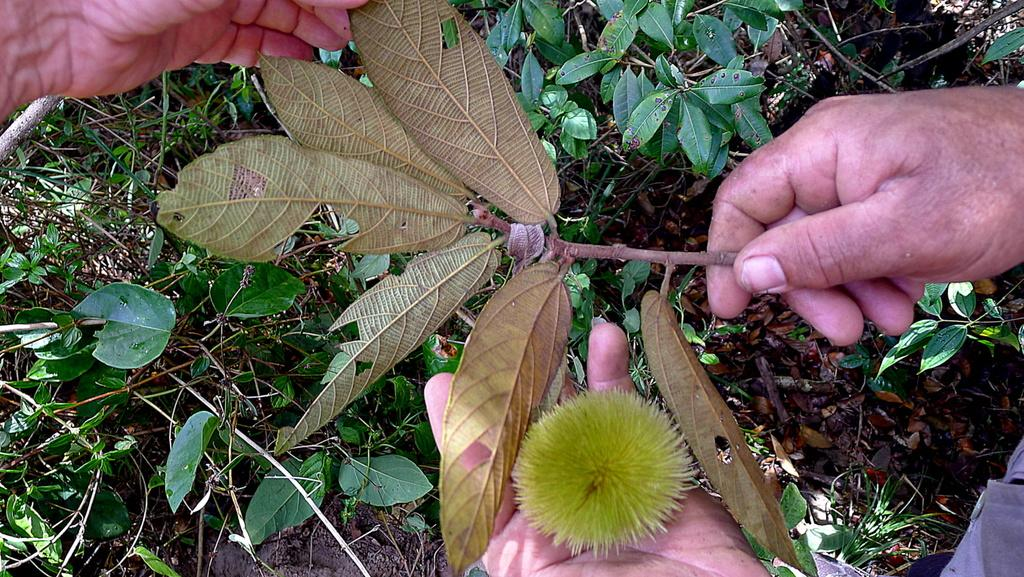Who or what is present in the image? There is a person in the image. What is the person holding in the image? The person is holding a stem of a plant. Are there any other plants visible in the image? Yes, there are other plants visible on the floor. What type of bait is the person using to catch fish in the image? There is no indication of fishing or bait in the image; the person is holding a stem of a plant. 